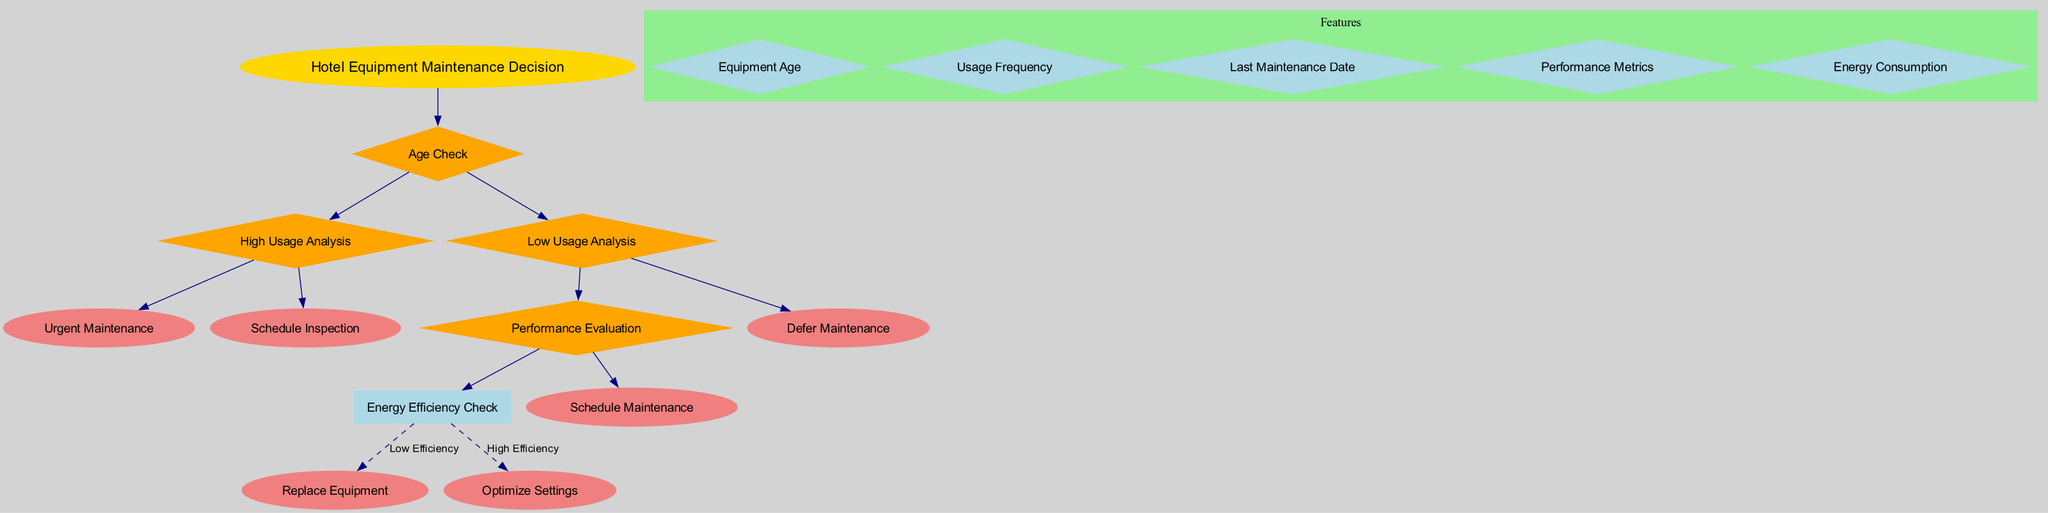What is the root node of the diagram? The root node is the starting point of the decision tree. According to the data provided, the root node is "Hotel Equipment Maintenance Decision."
Answer: Hotel Equipment Maintenance Decision How many features are there in the diagram? The number of features is listed in the data provided. There are five features: Equipment Age, Usage Frequency, Last Maintenance Date, Performance Metrics, and Energy Consumption.
Answer: 5 What is the first decision node listed? The first decision node is the top node under the root, which directs the decision-making process. According to the data, this is "Age Check."
Answer: Age Check What are the two child nodes of "Age Check"? Examining the connections from the "Age Check" decision node, we see it has two child nodes: "High Usage Analysis" and "Low Usage Analysis."
Answer: High Usage Analysis, Low Usage Analysis What does "High Usage Analysis" lead to? Following the flow from "High Usage Analysis," it leads to two possible outcomes: "Urgent Maintenance" and "Schedule Inspection."
Answer: Urgent Maintenance, Schedule Inspection What is the outcome if "Energy Efficiency Check" indicates low efficiency? If the "Energy Efficiency Check" indicates low efficiency, the flow directs to "Replace Equipment." This is specified as the resulting action based on the connection data.
Answer: Replace Equipment Which node connects to "Optimize Settings"? The connection to "Optimize Settings" comes from the "Energy Efficiency Check" when it indicates high efficiency. This determination is laid out in the connections data provided.
Answer: Energy Efficiency Check If the usage is low, which node evaluates performance? In the case of low usage, the diagram indicates that "Performance Evaluation" comes into play to assess the situation. This can be traced through the child nodes of "Low Usage Analysis."
Answer: Performance Evaluation What are the leaf nodes that lead to maintenance action? The leaf nodes associated with direct maintenance actions are "Urgent Maintenance," "Schedule Maintenance," and "Defer Maintenance." These nodes culminate from the various pathways through the decision tree.
Answer: Urgent Maintenance, Schedule Maintenance, Defer Maintenance 